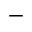Convert formula to latex. <formula><loc_0><loc_0><loc_500><loc_500>-</formula> 